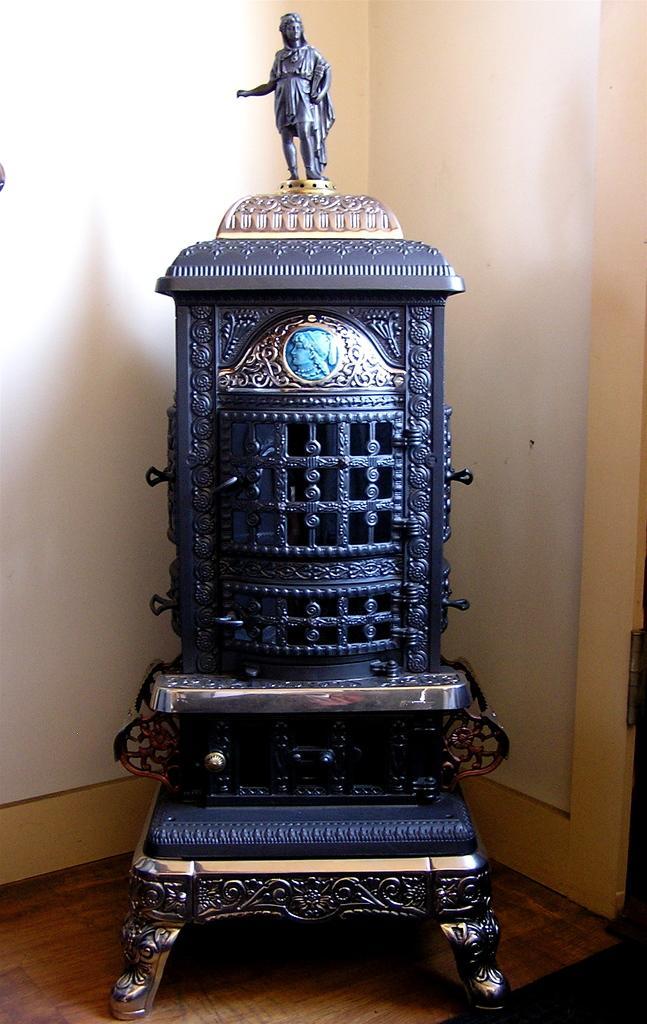How would you summarize this image in a sentence or two? In this picture I can observe an object which is looking like an antique in the middle of the picture. In the background I can observe wall. 